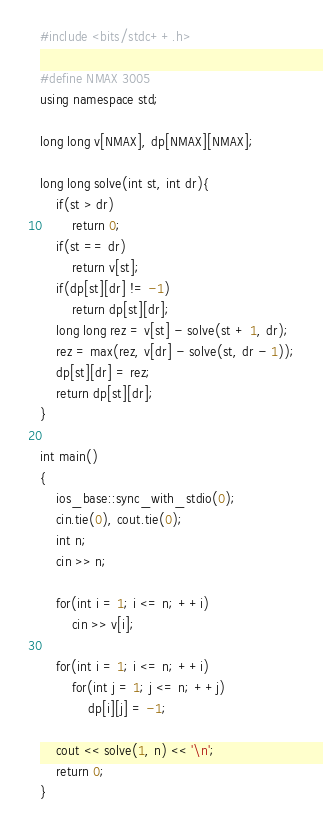<code> <loc_0><loc_0><loc_500><loc_500><_C++_>#include <bits/stdc++.h>

#define NMAX 3005
using namespace std;

long long v[NMAX], dp[NMAX][NMAX];

long long solve(int st, int dr){
    if(st > dr)
        return 0;
    if(st == dr)
        return v[st];
    if(dp[st][dr] != -1)
        return dp[st][dr];
    long long rez = v[st] - solve(st + 1, dr);
    rez = max(rez, v[dr] - solve(st, dr - 1));
    dp[st][dr] = rez;
    return dp[st][dr];
}

int main()
{
    ios_base::sync_with_stdio(0);
    cin.tie(0), cout.tie(0);
    int n;
    cin >> n;

    for(int i = 1; i <= n; ++i)
        cin >> v[i];

    for(int i = 1; i <= n; ++i)
        for(int j = 1; j <= n; ++j)
            dp[i][j] = -1;

    cout << solve(1, n) << '\n';
    return 0;
}
</code> 